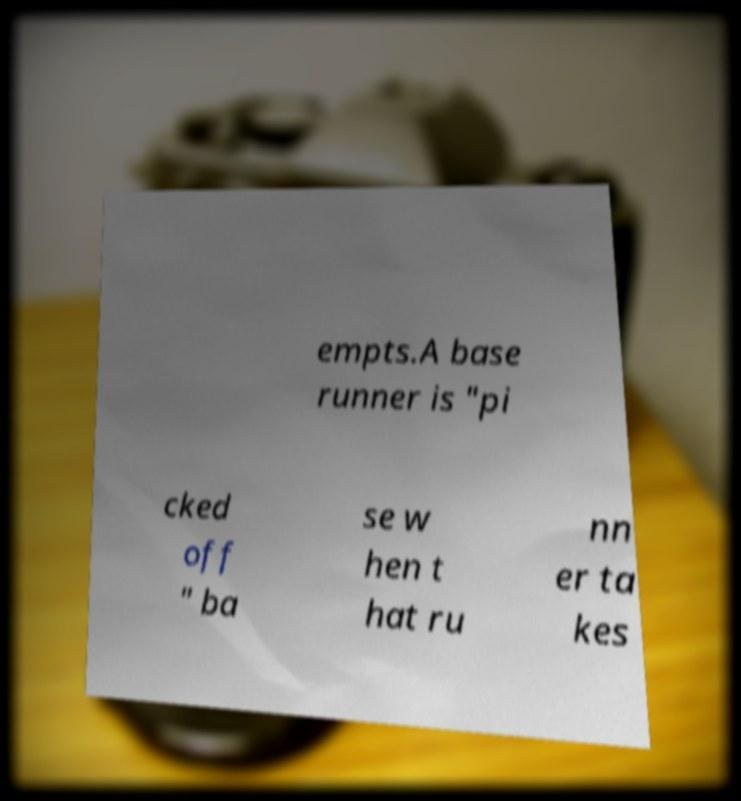Can you accurately transcribe the text from the provided image for me? empts.A base runner is "pi cked off " ba se w hen t hat ru nn er ta kes 